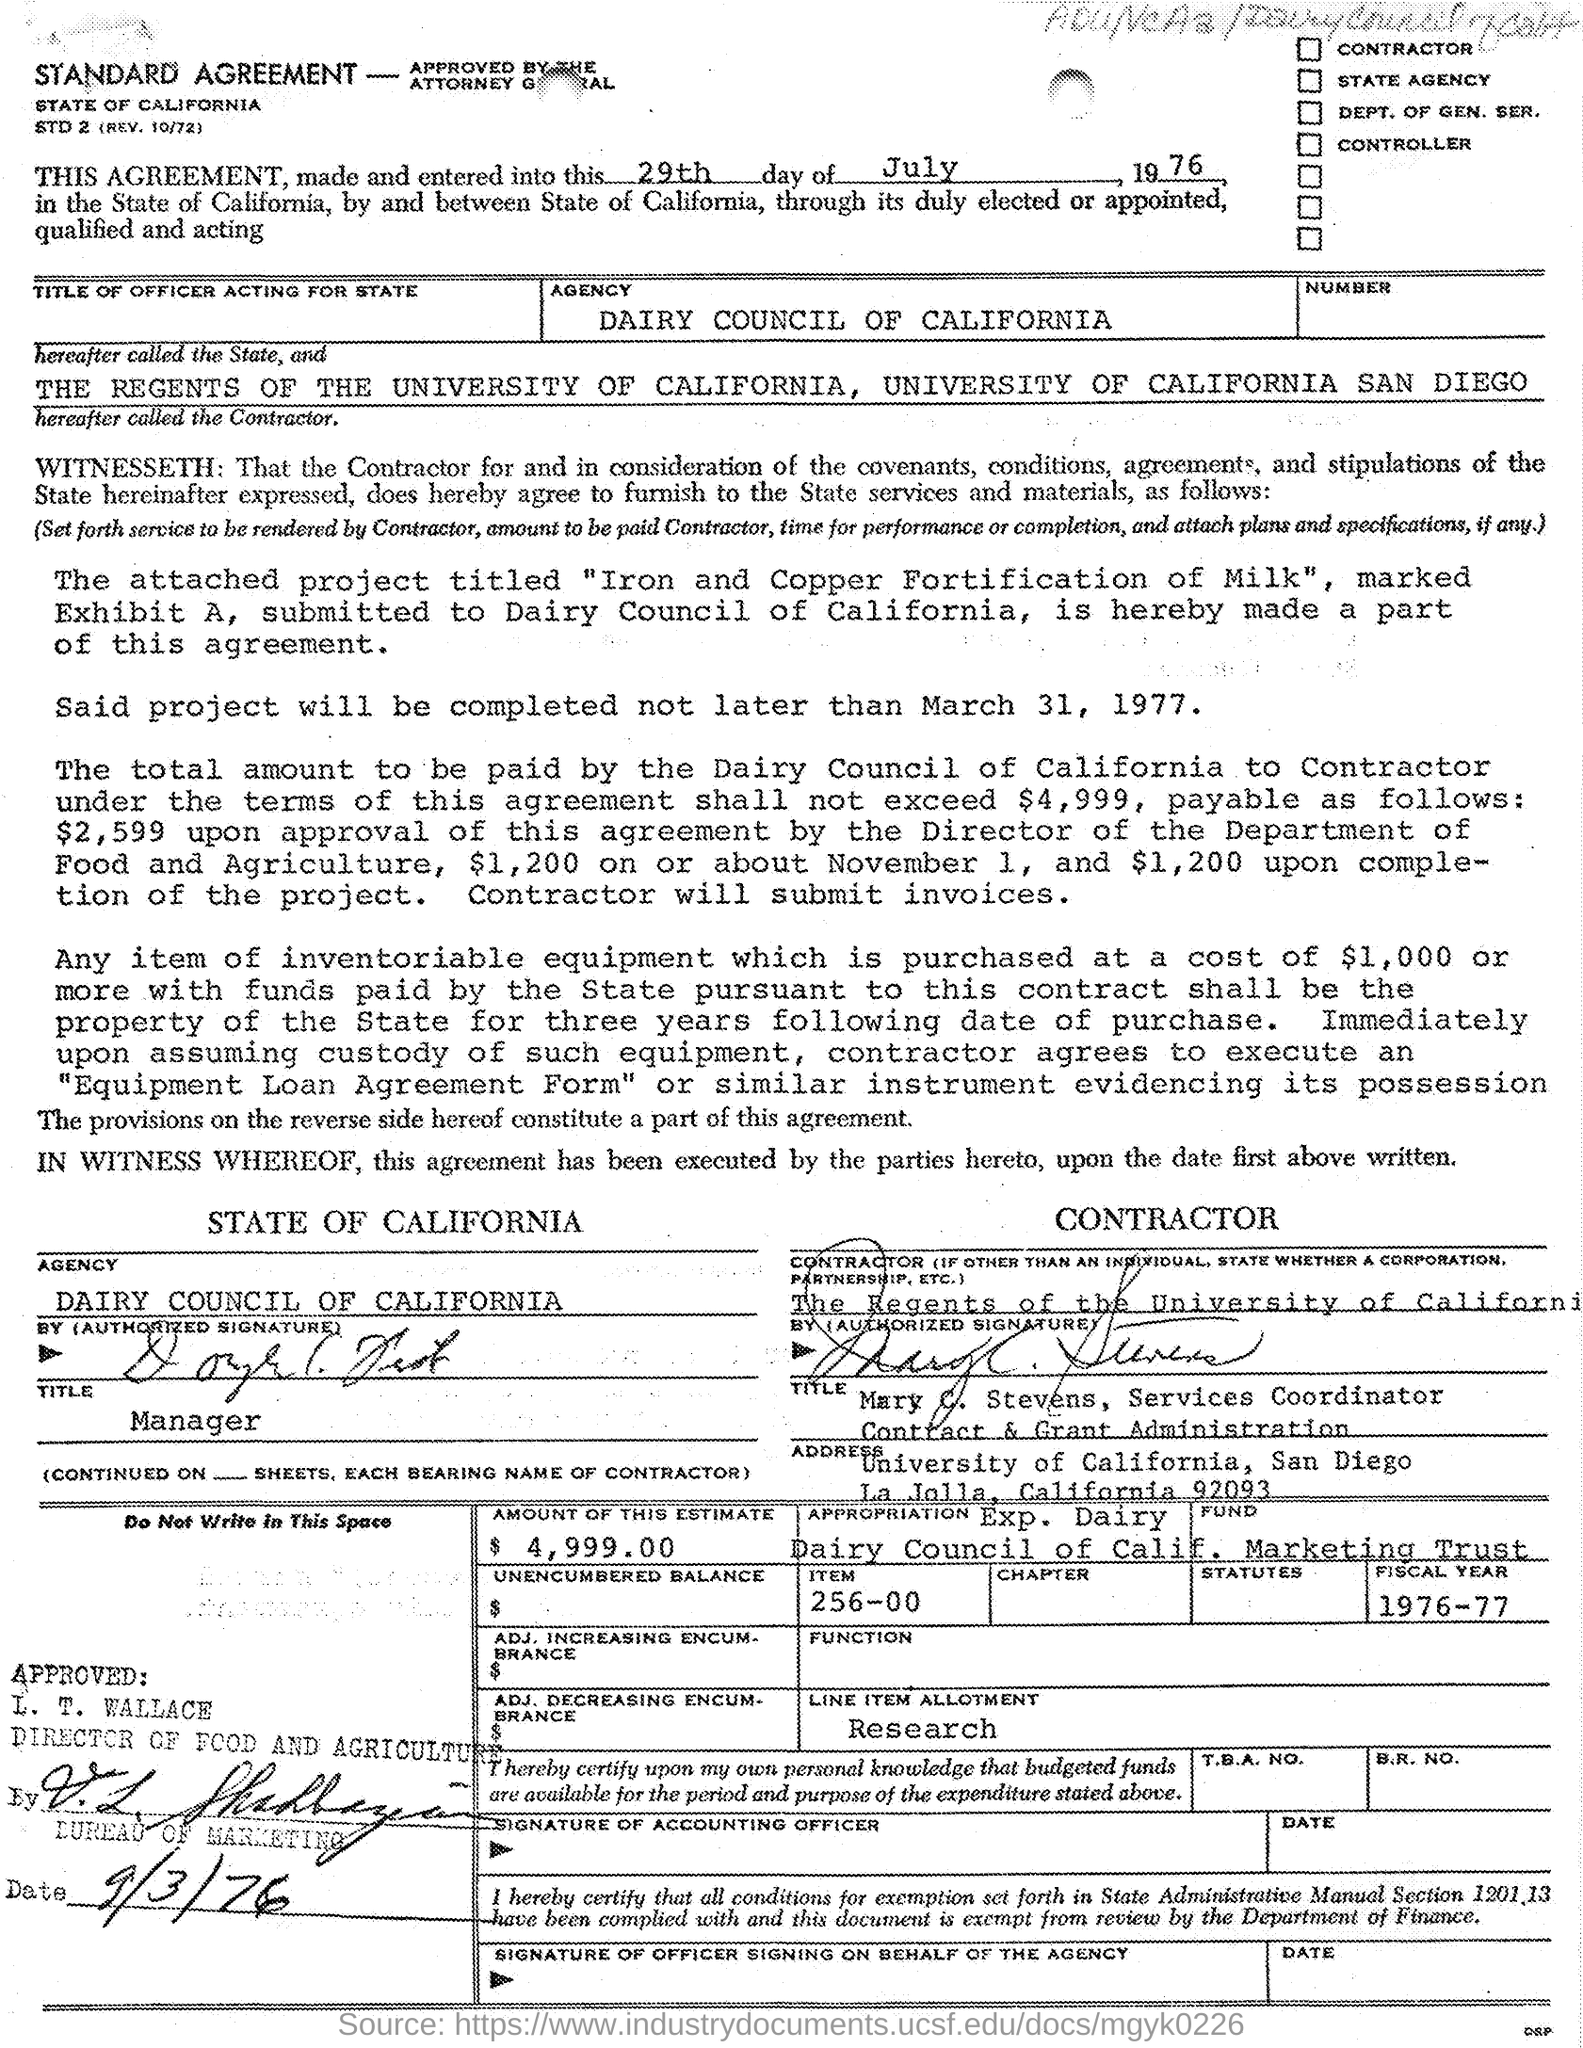Identify some key points in this picture. The agreement was made on the 29th day of July, 1976, as per the document given. This agreement was approved on September 3, 1976. The fiscal year mentioned in the document is 1976-1977. 